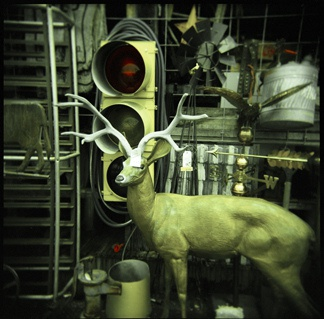Describe the objects in this image and their specific colors. I can see traffic light in black, olive, khaki, and darkgreen tones and bird in black and darkgreen tones in this image. 